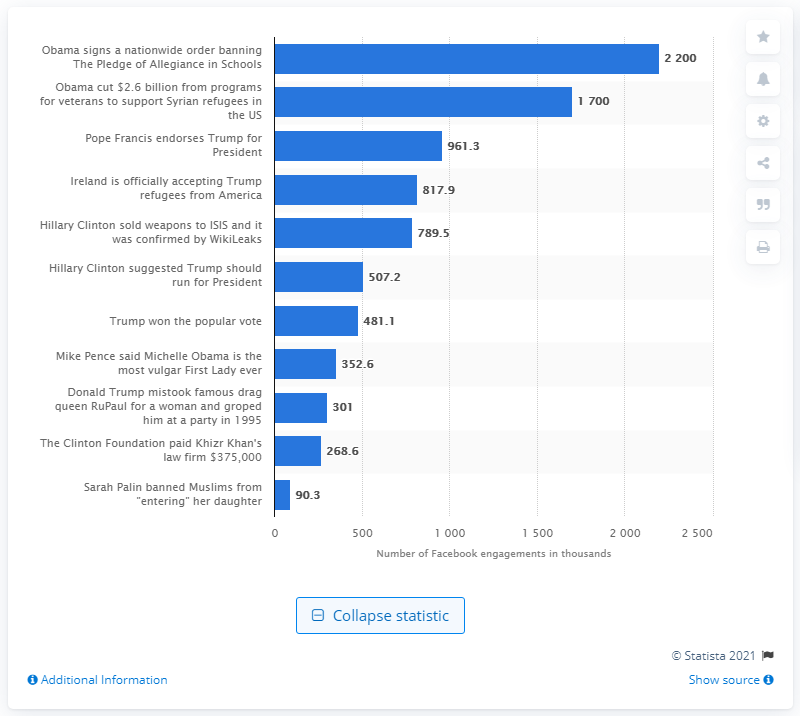Are there any fake news stories on this list that were particularly damaging or had significant consequences? While the image doesn't specify the consequences, fake news stories about political figures or significant policy claims, such as the top shared story regarding the ban of The Pledge of Allegiance or the sale of weapons to ISIS by Hillary Clinton, can be particularly damaging by influencing public opinion and potentially affecting election outcomes due to their emotive nature. 